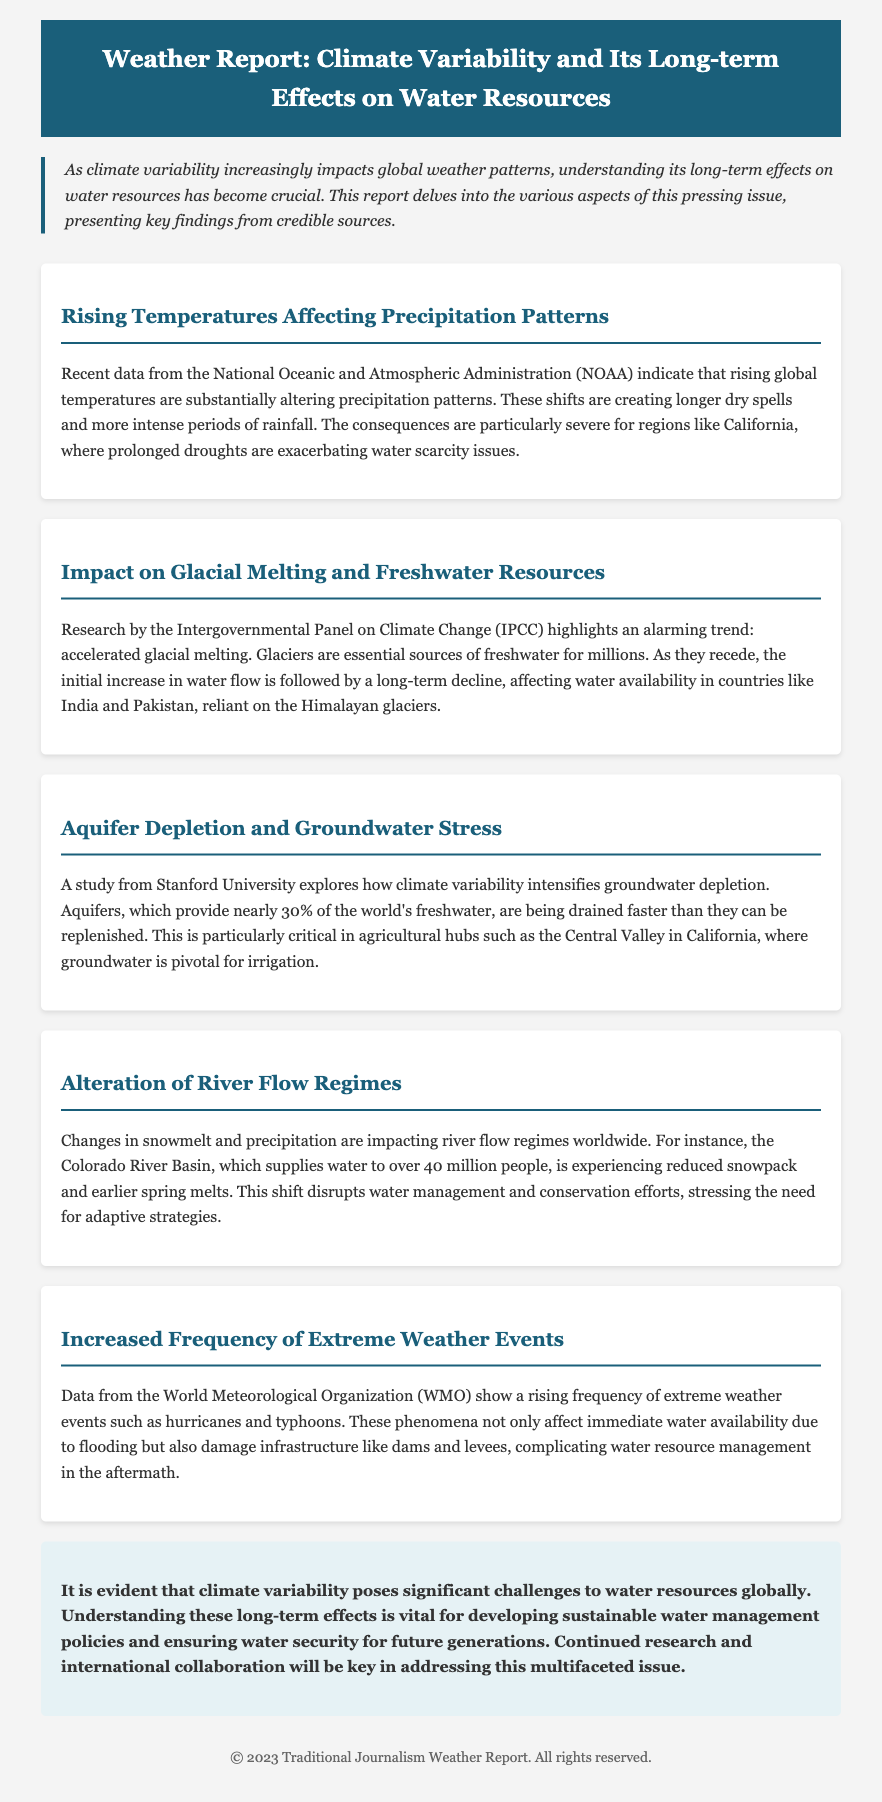what is the primary focus of the report? The report focuses on the long-term effects of climate variability on water resources.
Answer: long-term effects of climate variability on water resources who provided the recent data about precipitation patterns? The recent data about precipitation patterns was provided by the National Oceanic and Atmospheric Administration.
Answer: National Oceanic and Atmospheric Administration which river basin is mentioned as experiencing reduced snowpack? The mentioned river basin experiencing reduced snowpack is the Colorado River Basin.
Answer: Colorado River Basin what natural resource is crucial for irrigation in the Central Valley of California? The crucial natural resource for irrigation in the Central Valley of California is groundwater.
Answer: groundwater what are the consequences of accelerated glacial melting in the Himalayas? The consequences include a long-term decline in water availability for countries dependent on the Himalayan glaciers.
Answer: long-term decline in water availability how many people does the Colorado River Basin supply water to? The Colorado River Basin supplies water to over 40 million people.
Answer: over 40 million people what trend is highlighted by the World Meteorological Organization regarding weather events? The highlighted trend is the increased frequency of extreme weather events.
Answer: increased frequency of extreme weather events which area is particularly critical for groundwater depletion? The area particularly critical for groundwater depletion is the Central Valley in California.
Answer: Central Valley in California 